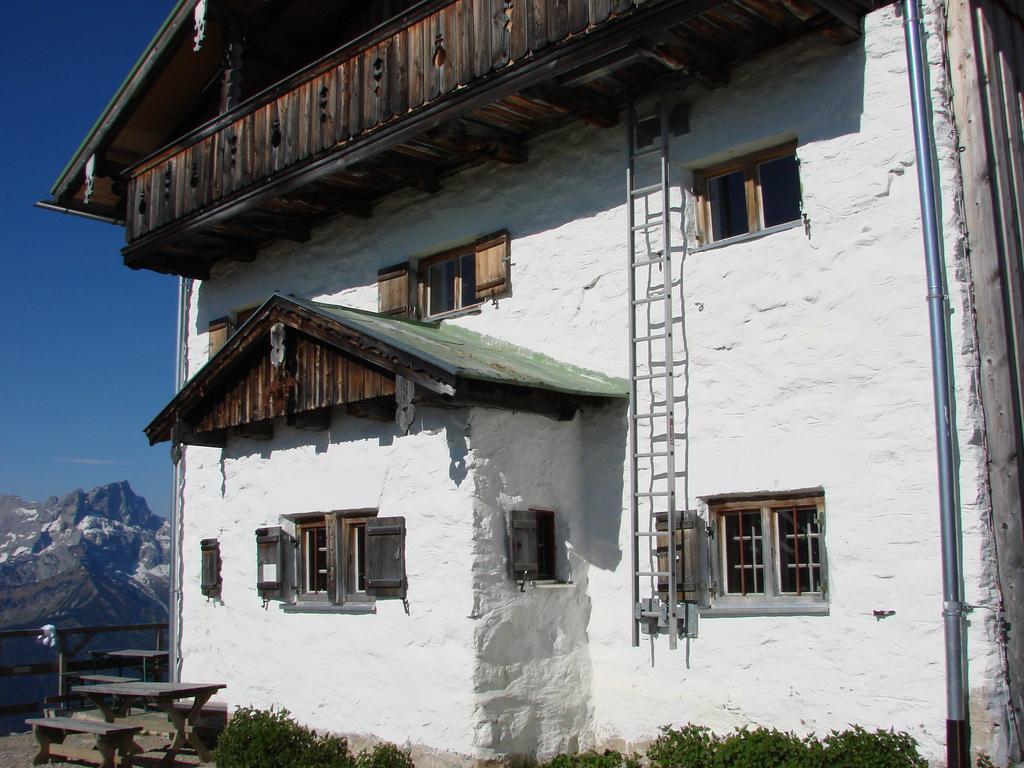Describe this image in one or two sentences. In this image we can see a building with windows, a ladder, wooden railing and a metal pipe, there are few benches and plants in front of the building, there are few mountains and the sky on the left side of the image. 